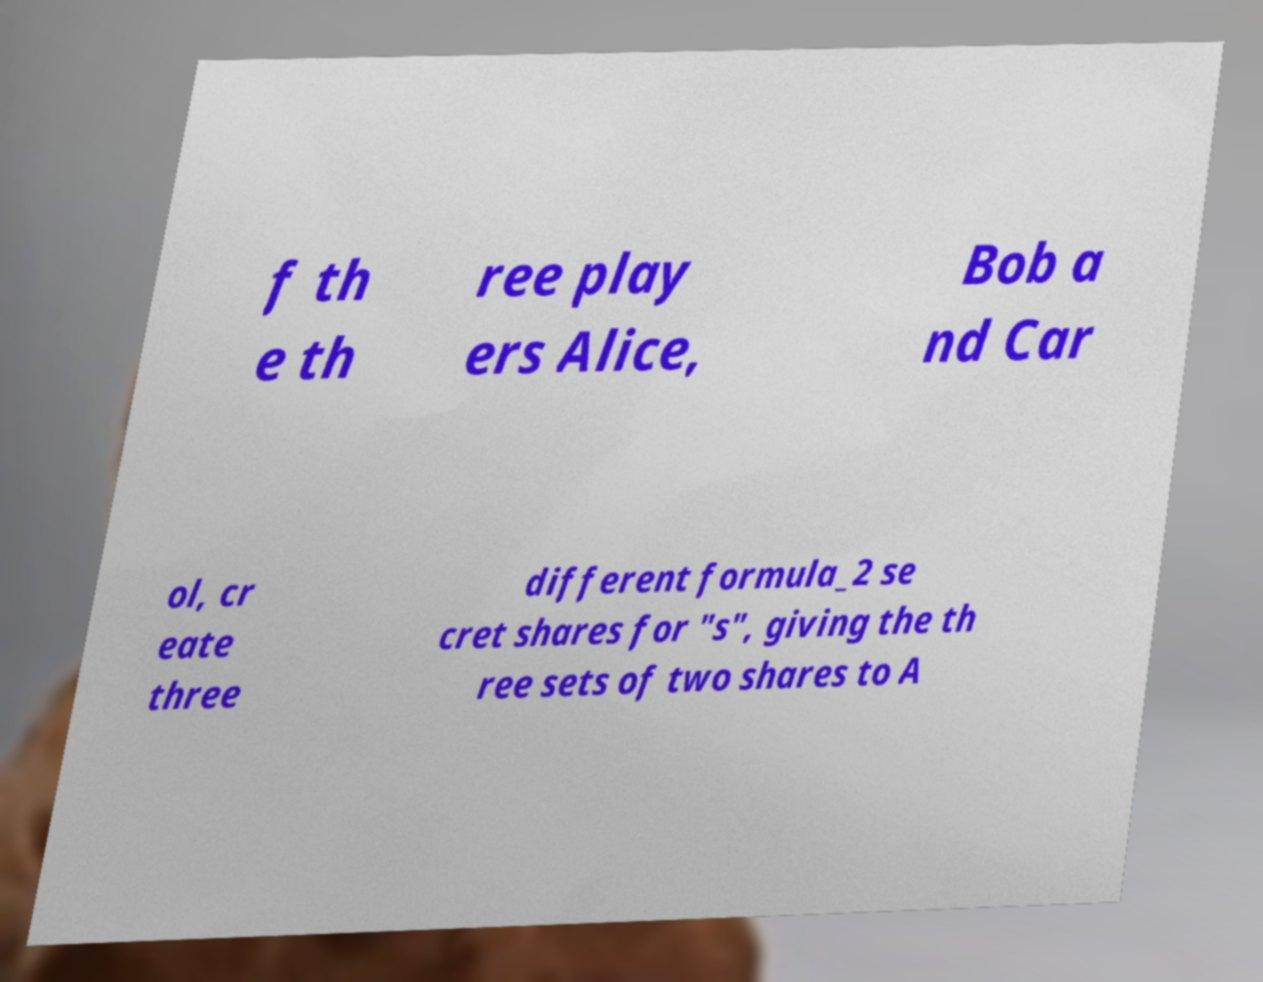For documentation purposes, I need the text within this image transcribed. Could you provide that? f th e th ree play ers Alice, Bob a nd Car ol, cr eate three different formula_2 se cret shares for "s", giving the th ree sets of two shares to A 